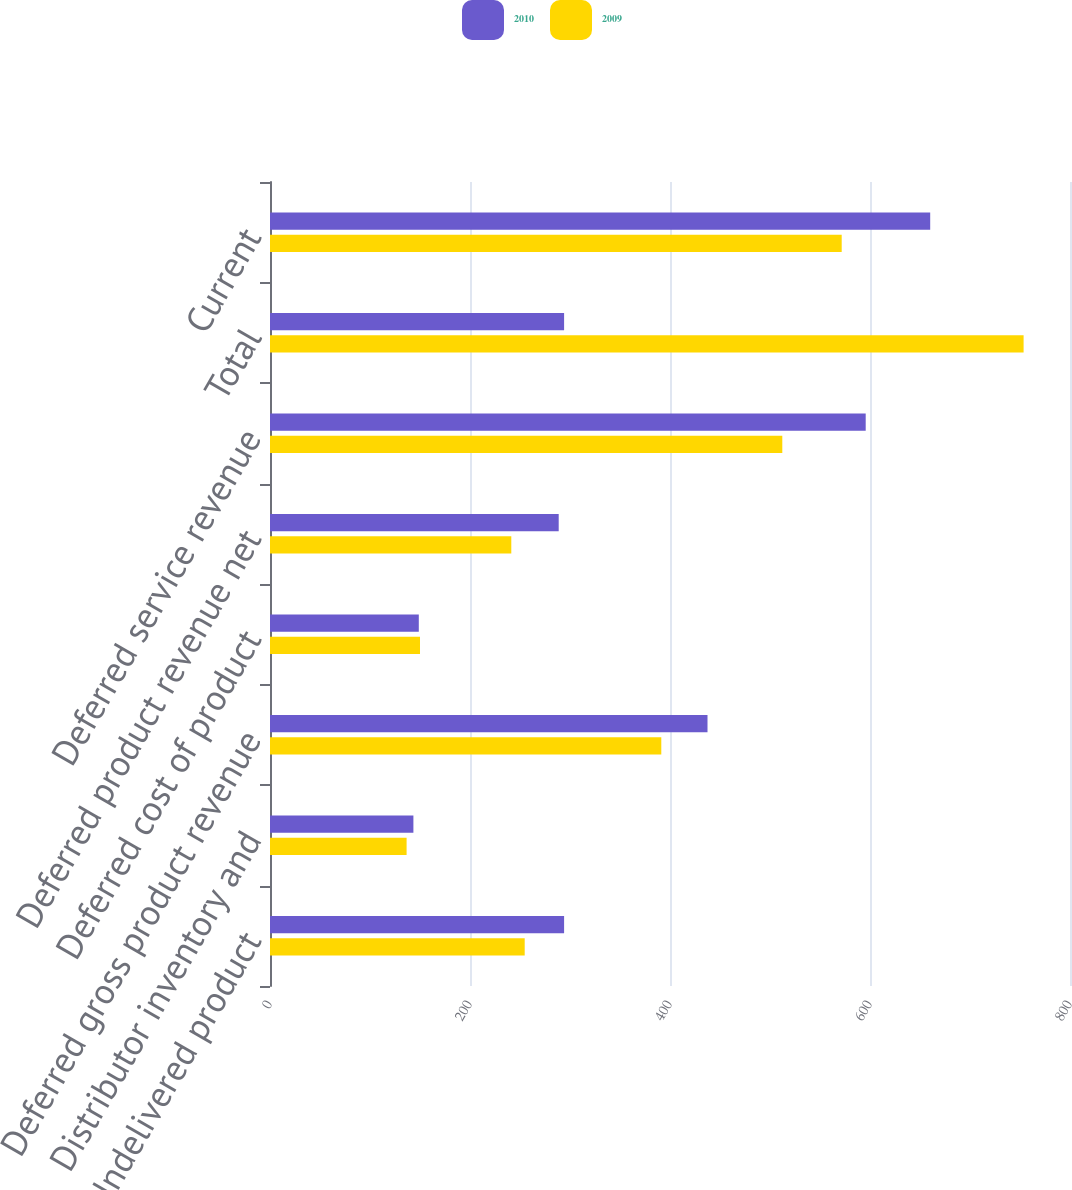Convert chart. <chart><loc_0><loc_0><loc_500><loc_500><stacked_bar_chart><ecel><fcel>Undelivered product<fcel>Distributor inventory and<fcel>Deferred gross product revenue<fcel>Deferred cost of product<fcel>Deferred product revenue net<fcel>Deferred service revenue<fcel>Total<fcel>Current<nl><fcel>2010<fcel>294.1<fcel>143.4<fcel>437.5<fcel>148.8<fcel>288.7<fcel>595.7<fcel>294.1<fcel>660.2<nl><fcel>2009<fcel>254.7<fcel>136.6<fcel>391.3<fcel>150<fcel>241.3<fcel>512.3<fcel>753.6<fcel>571.7<nl></chart> 